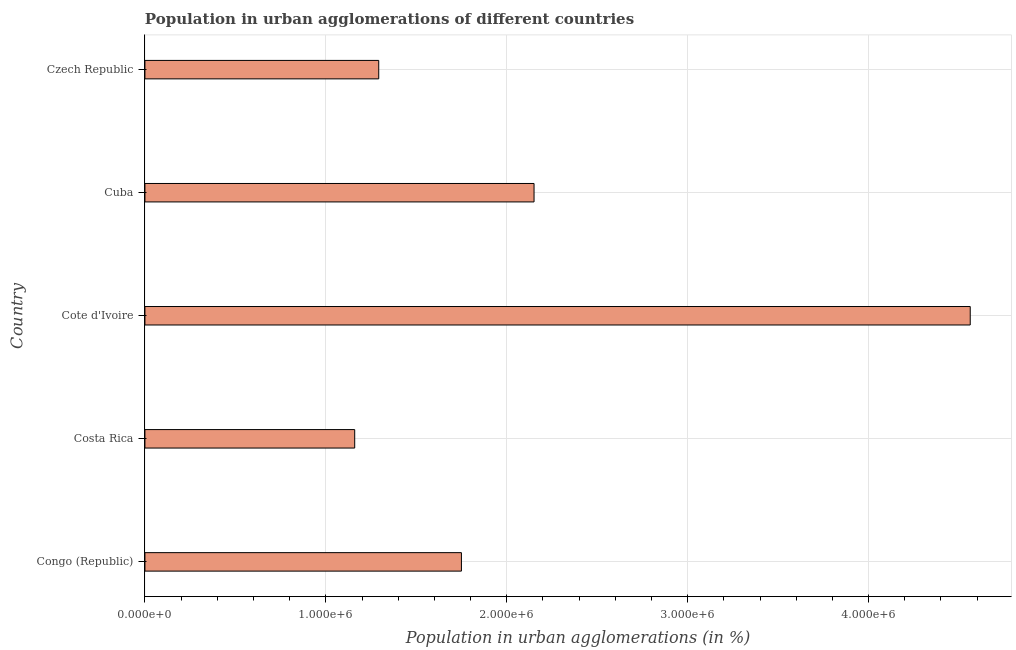Does the graph contain grids?
Your answer should be very brief. Yes. What is the title of the graph?
Provide a succinct answer. Population in urban agglomerations of different countries. What is the label or title of the X-axis?
Keep it short and to the point. Population in urban agglomerations (in %). What is the label or title of the Y-axis?
Offer a terse response. Country. What is the population in urban agglomerations in Czech Republic?
Ensure brevity in your answer.  1.29e+06. Across all countries, what is the maximum population in urban agglomerations?
Your answer should be compact. 4.56e+06. Across all countries, what is the minimum population in urban agglomerations?
Provide a succinct answer. 1.16e+06. In which country was the population in urban agglomerations maximum?
Keep it short and to the point. Cote d'Ivoire. In which country was the population in urban agglomerations minimum?
Ensure brevity in your answer.  Costa Rica. What is the sum of the population in urban agglomerations?
Ensure brevity in your answer.  1.09e+07. What is the difference between the population in urban agglomerations in Cote d'Ivoire and Cuba?
Provide a succinct answer. 2.41e+06. What is the average population in urban agglomerations per country?
Keep it short and to the point. 2.18e+06. What is the median population in urban agglomerations?
Provide a succinct answer. 1.75e+06. What is the ratio of the population in urban agglomerations in Costa Rica to that in Cuba?
Offer a terse response. 0.54. Is the difference between the population in urban agglomerations in Congo (Republic) and Costa Rica greater than the difference between any two countries?
Keep it short and to the point. No. What is the difference between the highest and the second highest population in urban agglomerations?
Your response must be concise. 2.41e+06. Is the sum of the population in urban agglomerations in Congo (Republic) and Cuba greater than the maximum population in urban agglomerations across all countries?
Your answer should be very brief. No. What is the difference between the highest and the lowest population in urban agglomerations?
Your answer should be very brief. 3.40e+06. In how many countries, is the population in urban agglomerations greater than the average population in urban agglomerations taken over all countries?
Your answer should be very brief. 1. How many bars are there?
Provide a short and direct response. 5. Are the values on the major ticks of X-axis written in scientific E-notation?
Give a very brief answer. Yes. What is the Population in urban agglomerations (in %) of Congo (Republic)?
Keep it short and to the point. 1.75e+06. What is the Population in urban agglomerations (in %) of Costa Rica?
Give a very brief answer. 1.16e+06. What is the Population in urban agglomerations (in %) of Cote d'Ivoire?
Your answer should be very brief. 4.56e+06. What is the Population in urban agglomerations (in %) in Cuba?
Your answer should be compact. 2.15e+06. What is the Population in urban agglomerations (in %) of Czech Republic?
Provide a short and direct response. 1.29e+06. What is the difference between the Population in urban agglomerations (in %) in Congo (Republic) and Costa Rica?
Provide a short and direct response. 5.90e+05. What is the difference between the Population in urban agglomerations (in %) in Congo (Republic) and Cote d'Ivoire?
Your answer should be very brief. -2.81e+06. What is the difference between the Population in urban agglomerations (in %) in Congo (Republic) and Cuba?
Make the answer very short. -4.01e+05. What is the difference between the Population in urban agglomerations (in %) in Congo (Republic) and Czech Republic?
Give a very brief answer. 4.57e+05. What is the difference between the Population in urban agglomerations (in %) in Costa Rica and Cote d'Ivoire?
Make the answer very short. -3.40e+06. What is the difference between the Population in urban agglomerations (in %) in Costa Rica and Cuba?
Give a very brief answer. -9.91e+05. What is the difference between the Population in urban agglomerations (in %) in Costa Rica and Czech Republic?
Offer a terse response. -1.33e+05. What is the difference between the Population in urban agglomerations (in %) in Cote d'Ivoire and Cuba?
Offer a very short reply. 2.41e+06. What is the difference between the Population in urban agglomerations (in %) in Cote d'Ivoire and Czech Republic?
Give a very brief answer. 3.27e+06. What is the difference between the Population in urban agglomerations (in %) in Cuba and Czech Republic?
Give a very brief answer. 8.58e+05. What is the ratio of the Population in urban agglomerations (in %) in Congo (Republic) to that in Costa Rica?
Offer a very short reply. 1.51. What is the ratio of the Population in urban agglomerations (in %) in Congo (Republic) to that in Cote d'Ivoire?
Ensure brevity in your answer.  0.38. What is the ratio of the Population in urban agglomerations (in %) in Congo (Republic) to that in Cuba?
Ensure brevity in your answer.  0.81. What is the ratio of the Population in urban agglomerations (in %) in Congo (Republic) to that in Czech Republic?
Give a very brief answer. 1.35. What is the ratio of the Population in urban agglomerations (in %) in Costa Rica to that in Cote d'Ivoire?
Provide a succinct answer. 0.25. What is the ratio of the Population in urban agglomerations (in %) in Costa Rica to that in Cuba?
Your response must be concise. 0.54. What is the ratio of the Population in urban agglomerations (in %) in Costa Rica to that in Czech Republic?
Provide a short and direct response. 0.9. What is the ratio of the Population in urban agglomerations (in %) in Cote d'Ivoire to that in Cuba?
Make the answer very short. 2.12. What is the ratio of the Population in urban agglomerations (in %) in Cote d'Ivoire to that in Czech Republic?
Give a very brief answer. 3.53. What is the ratio of the Population in urban agglomerations (in %) in Cuba to that in Czech Republic?
Keep it short and to the point. 1.66. 